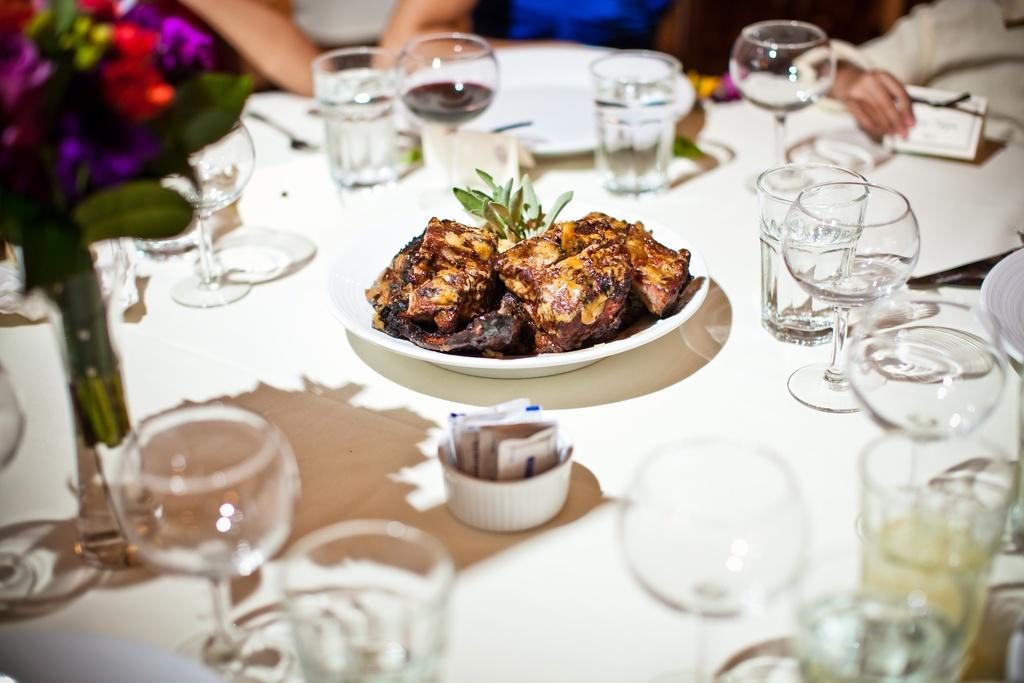What type of furniture is present in the image? There is a table in the image. What items can be seen on the table? There are glasses, plates, a bowl, a flower vase, a board, spoons, and a plate containing food on the table. Can you describe the contents of the plate with food? The plate contains food, but the specific type of food is not visible in the image. Are there any people present in the image? Yes, there are people in the background of the image. What type of mitten is being used to serve the food on the plate? There is no mitten present in the image; the food is served using spoons and other utensils visible on the table. 